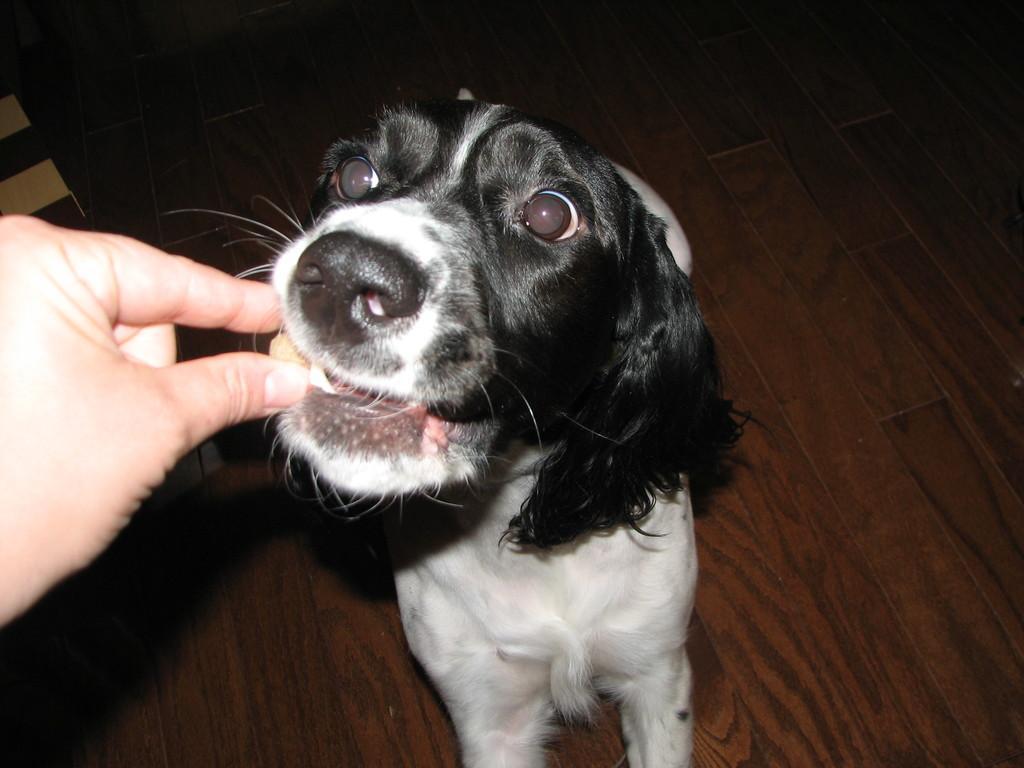Can you describe this image briefly? In this image, we can see a person feeding a dog. At the bottom, there is a floor. 